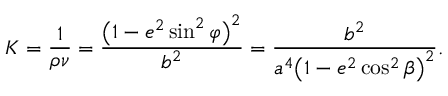Convert formula to latex. <formula><loc_0><loc_0><loc_500><loc_500>K = { \frac { 1 } { \rho \nu } } = { \frac { { \left ( } 1 - e ^ { 2 } \sin ^ { 2 } \varphi { \right ) } ^ { 2 } } { b ^ { 2 } } } = { \frac { b ^ { 2 } } { a ^ { 4 } { \left ( } 1 - e ^ { 2 } \cos ^ { 2 } \beta { \right ) } ^ { 2 } } } .</formula> 